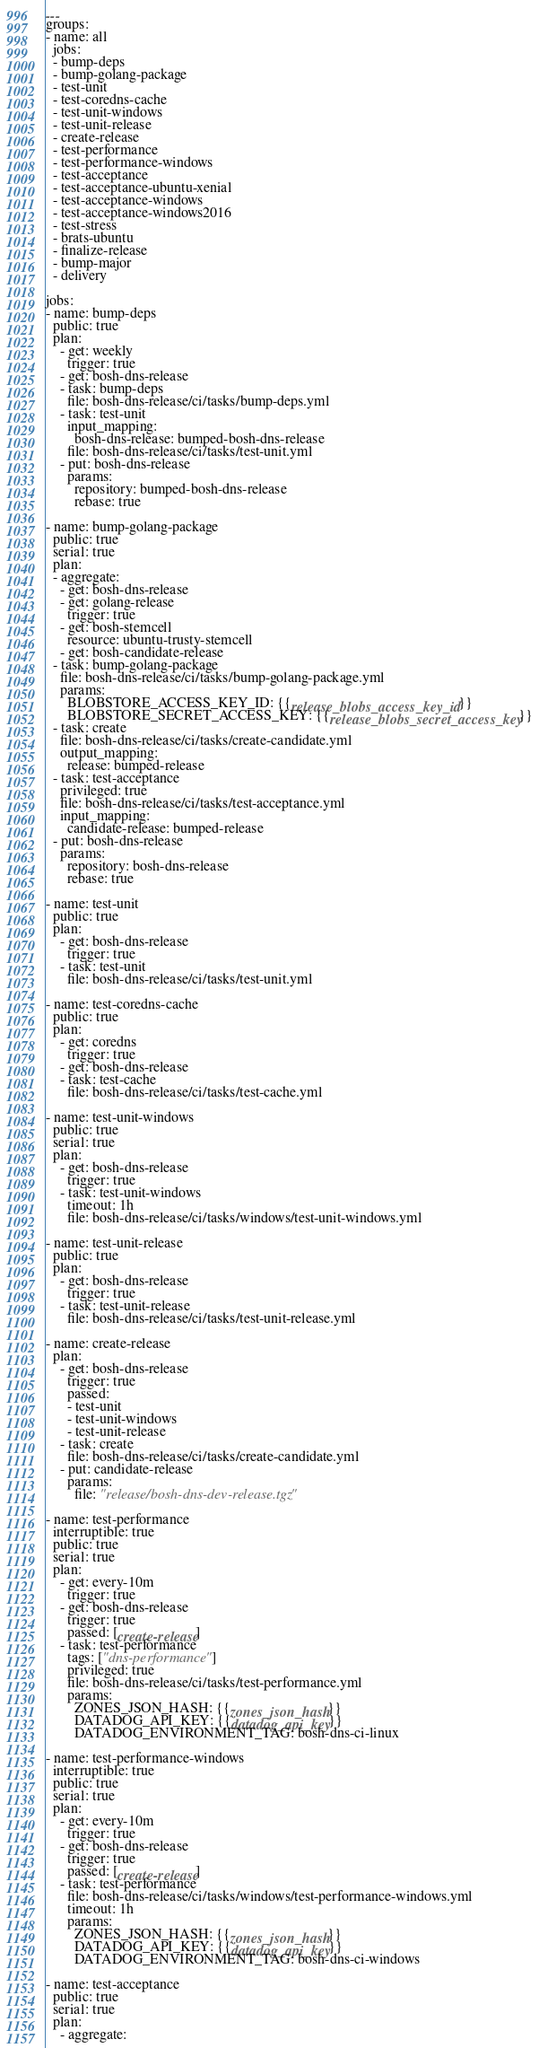<code> <loc_0><loc_0><loc_500><loc_500><_YAML_>---
groups:
- name: all
  jobs:
  - bump-deps
  - bump-golang-package
  - test-unit
  - test-coredns-cache
  - test-unit-windows
  - test-unit-release
  - create-release
  - test-performance
  - test-performance-windows
  - test-acceptance
  - test-acceptance-ubuntu-xenial
  - test-acceptance-windows
  - test-acceptance-windows2016
  - test-stress
  - brats-ubuntu
  - finalize-release
  - bump-major
  - delivery

jobs:
- name: bump-deps
  public: true
  plan:
    - get: weekly
      trigger: true
    - get: bosh-dns-release
    - task: bump-deps
      file: bosh-dns-release/ci/tasks/bump-deps.yml
    - task: test-unit
      input_mapping:
        bosh-dns-release: bumped-bosh-dns-release
      file: bosh-dns-release/ci/tasks/test-unit.yml
    - put: bosh-dns-release
      params:
        repository: bumped-bosh-dns-release
        rebase: true

- name: bump-golang-package
  public: true
  serial: true
  plan:
  - aggregate:
    - get: bosh-dns-release
    - get: golang-release
      trigger: true
    - get: bosh-stemcell
      resource: ubuntu-trusty-stemcell
    - get: bosh-candidate-release
  - task: bump-golang-package
    file: bosh-dns-release/ci/tasks/bump-golang-package.yml
    params:
      BLOBSTORE_ACCESS_KEY_ID: {{release_blobs_access_key_id}}
      BLOBSTORE_SECRET_ACCESS_KEY: {{release_blobs_secret_access_key}}
  - task: create
    file: bosh-dns-release/ci/tasks/create-candidate.yml
    output_mapping:
      release: bumped-release
  - task: test-acceptance
    privileged: true
    file: bosh-dns-release/ci/tasks/test-acceptance.yml
    input_mapping:
      candidate-release: bumped-release
  - put: bosh-dns-release
    params:
      repository: bosh-dns-release
      rebase: true

- name: test-unit
  public: true
  plan:
    - get: bosh-dns-release
      trigger: true
    - task: test-unit
      file: bosh-dns-release/ci/tasks/test-unit.yml

- name: test-coredns-cache
  public: true
  plan:
    - get: coredns
      trigger: true
    - get: bosh-dns-release
    - task: test-cache
      file: bosh-dns-release/ci/tasks/test-cache.yml

- name: test-unit-windows
  public: true
  serial: true
  plan:
    - get: bosh-dns-release
      trigger: true
    - task: test-unit-windows
      timeout: 1h
      file: bosh-dns-release/ci/tasks/windows/test-unit-windows.yml

- name: test-unit-release
  public: true
  plan:
    - get: bosh-dns-release
      trigger: true
    - task: test-unit-release
      file: bosh-dns-release/ci/tasks/test-unit-release.yml

- name: create-release
  plan:
    - get: bosh-dns-release
      trigger: true
      passed:
      - test-unit
      - test-unit-windows
      - test-unit-release
    - task: create
      file: bosh-dns-release/ci/tasks/create-candidate.yml
    - put: candidate-release
      params:
        file: "release/bosh-dns-dev-release.tgz"

- name: test-performance
  interruptible: true
  public: true
  serial: true
  plan:
    - get: every-10m
      trigger: true
    - get: bosh-dns-release
      trigger: true
      passed: [create-release]
    - task: test-performance
      tags: ["dns-performance"]
      privileged: true
      file: bosh-dns-release/ci/tasks/test-performance.yml
      params:
        ZONES_JSON_HASH: {{zones_json_hash}}
        DATADOG_API_KEY: {{datadog_api_key}}
        DATADOG_ENVIRONMENT_TAG: bosh-dns-ci-linux

- name: test-performance-windows
  interruptible: true
  public: true
  serial: true
  plan:
    - get: every-10m
      trigger: true
    - get: bosh-dns-release
      trigger: true
      passed: [create-release]
    - task: test-performance
      file: bosh-dns-release/ci/tasks/windows/test-performance-windows.yml
      timeout: 1h
      params:
        ZONES_JSON_HASH: {{zones_json_hash}}
        DATADOG_API_KEY: {{datadog_api_key}}
        DATADOG_ENVIRONMENT_TAG: bosh-dns-ci-windows

- name: test-acceptance
  public: true
  serial: true
  plan:
    - aggregate:</code> 